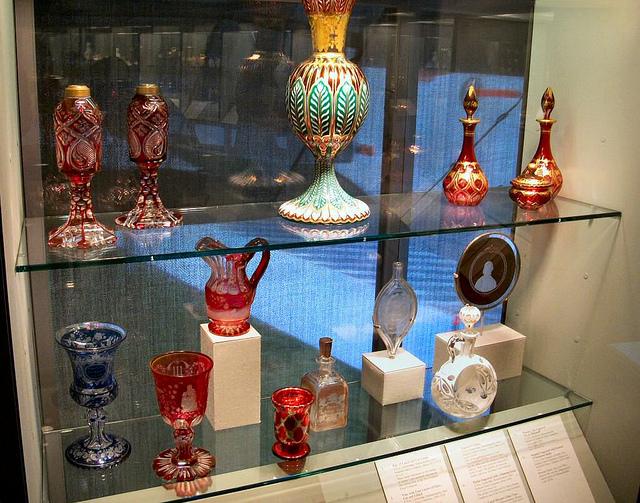What are most of these items made of?
Short answer required. Glass. How many vases are there?
Give a very brief answer. 12. What number of red vases are in this image?
Keep it brief. 7. 